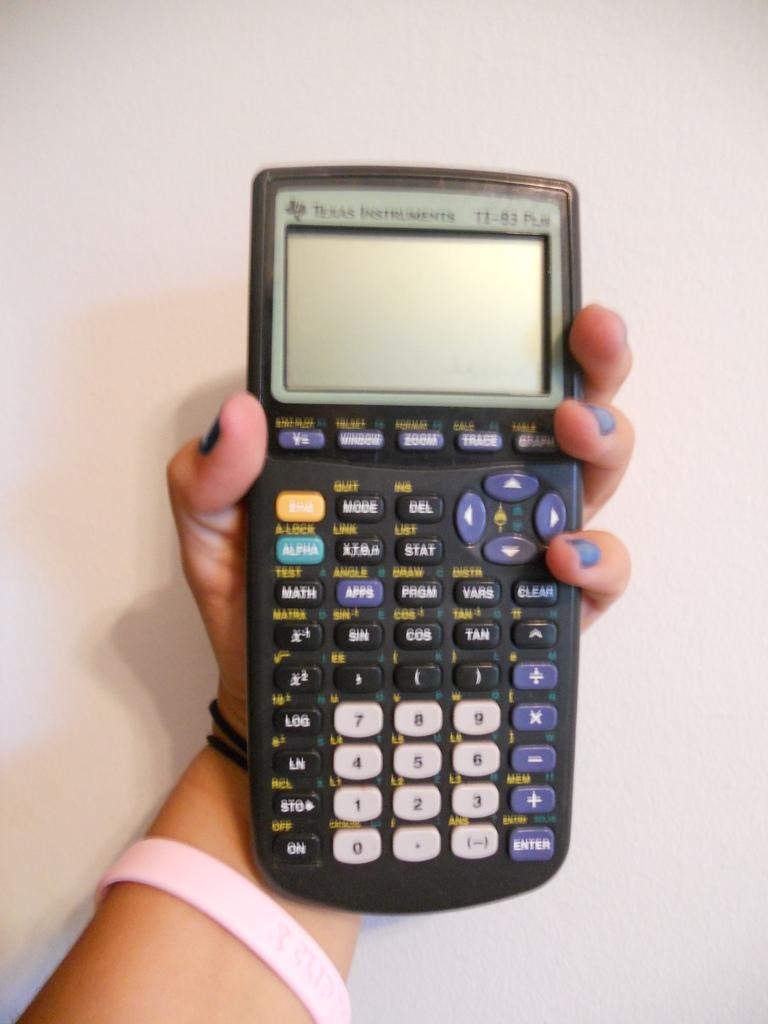What brand of graphing calculator?
Give a very brief answer. Texas instruments. What color are the numbered buttons?
Keep it short and to the point. White. 